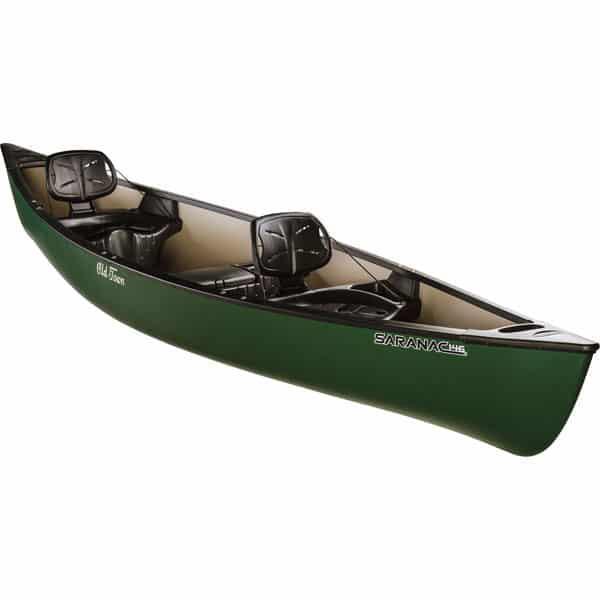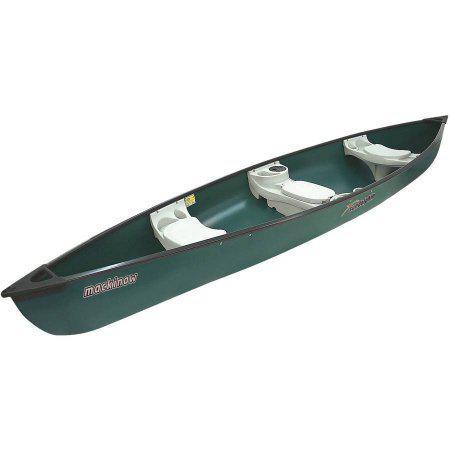The first image is the image on the left, the second image is the image on the right. Given the left and right images, does the statement "One of the boats does not contain seats with backrests." hold true? Answer yes or no. Yes. 